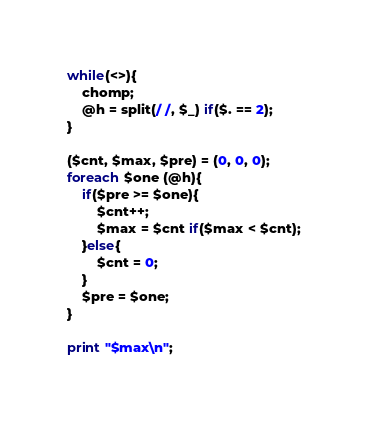<code> <loc_0><loc_0><loc_500><loc_500><_Perl_>while(<>){
	chomp;
	@h = split(/ /, $_) if($. == 2);
}

($cnt, $max, $pre) = (0, 0, 0);
foreach $one (@h){
	if($pre >= $one){
		$cnt++;
		$max = $cnt if($max < $cnt);
	}else{
		$cnt = 0;
	}
	$pre = $one;
}

print "$max\n";
</code> 